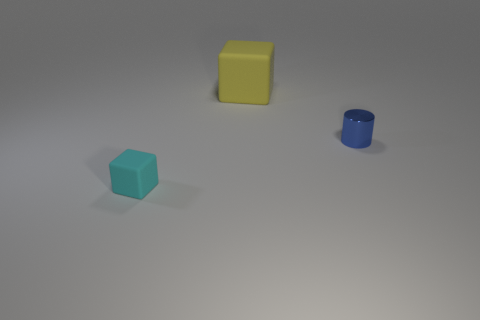Is there any other thing that is the same material as the blue object?
Your answer should be compact. No. Are there any other tiny blue cylinders that have the same material as the cylinder?
Keep it short and to the point. No. There is a small object that is to the right of the yellow cube; what material is it?
Offer a very short reply. Metal. The matte block that is the same size as the blue thing is what color?
Keep it short and to the point. Cyan. How many other objects are the same shape as the big yellow rubber thing?
Your answer should be compact. 1. There is a matte block left of the large yellow matte thing; what size is it?
Keep it short and to the point. Small. There is a matte block right of the cyan rubber block; what number of cyan matte cubes are behind it?
Offer a terse response. 0. What number of other objects are there of the same size as the shiny object?
Make the answer very short. 1. Do the rubber thing that is in front of the large thing and the large matte thing have the same shape?
Provide a short and direct response. Yes. How many objects are both in front of the yellow rubber object and behind the cyan cube?
Give a very brief answer. 1. 